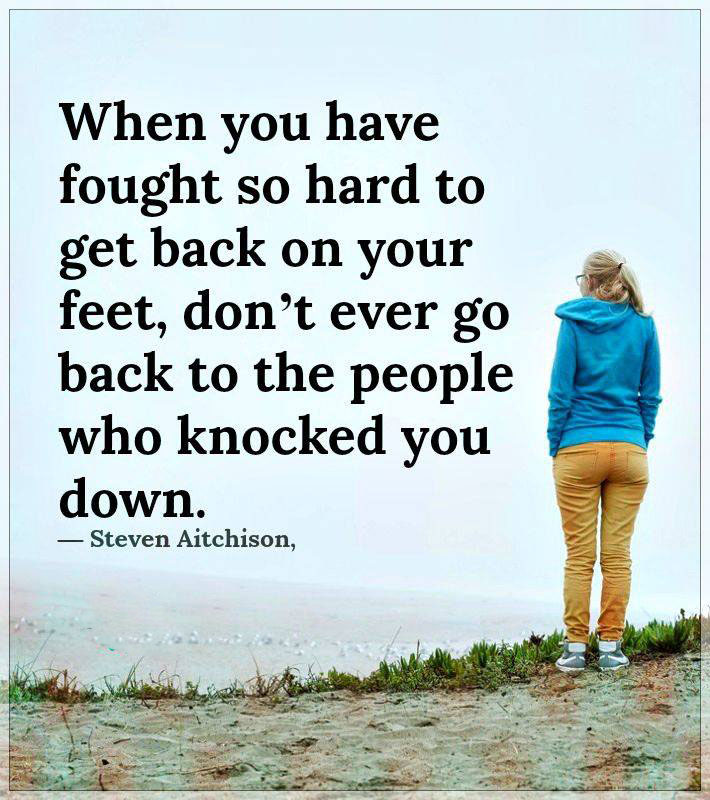What kind of emotions might this person be experiencing in this setting? Given the person's solitary stance, facing away from the camera towards a misty, open horizon, they might be experiencing a range of emotions such as contemplation, introspection, or even a sense of melancholy. The setting suggests a moment of reflection, possibly considering past decisions or future possibilities. 